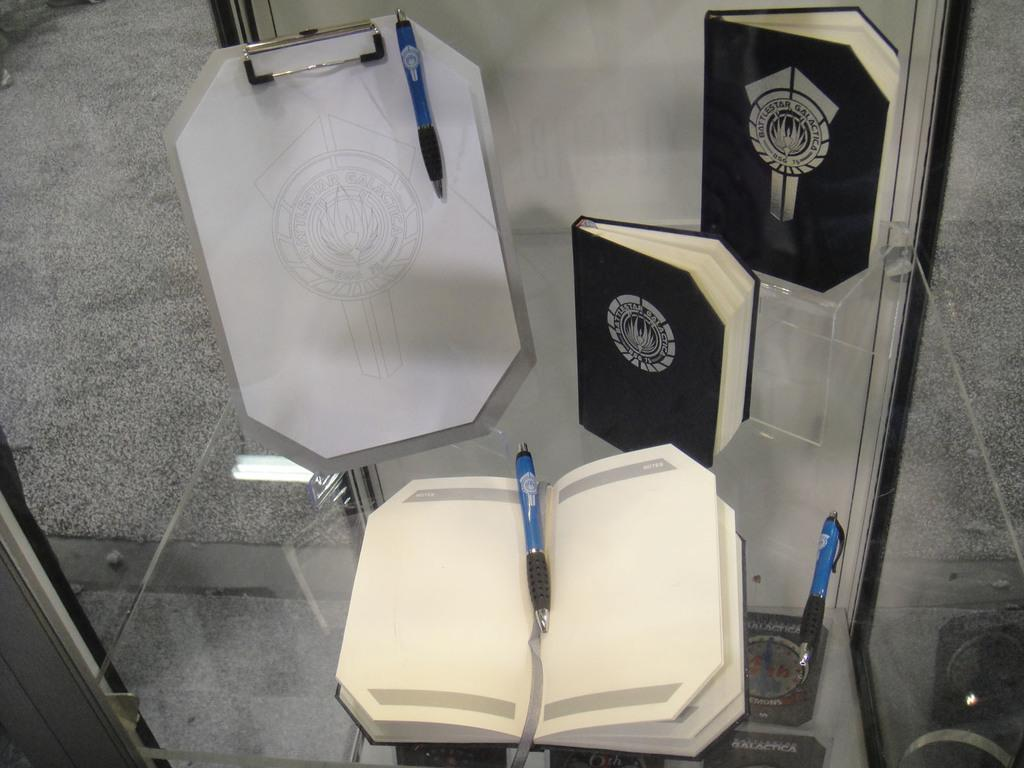What type of object is transparent and visible in the image? There is a transparent glass in the image. What items are placed on top of the transparent glass? Books and pens are placed on top of the transparent glass. What other object can be seen on the glass? There is a clipboard on the glass. What is located beneath the transparent glass? There are books under the transparent glass. How many apples are illuminated by the lamp in the image? A: There is no lamp or apples present in the image. 